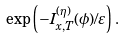Convert formula to latex. <formula><loc_0><loc_0><loc_500><loc_500>\exp { \left ( - I _ { x , T } ^ { ( \eta ) } ( \phi ) / \varepsilon \right ) } \, .</formula> 